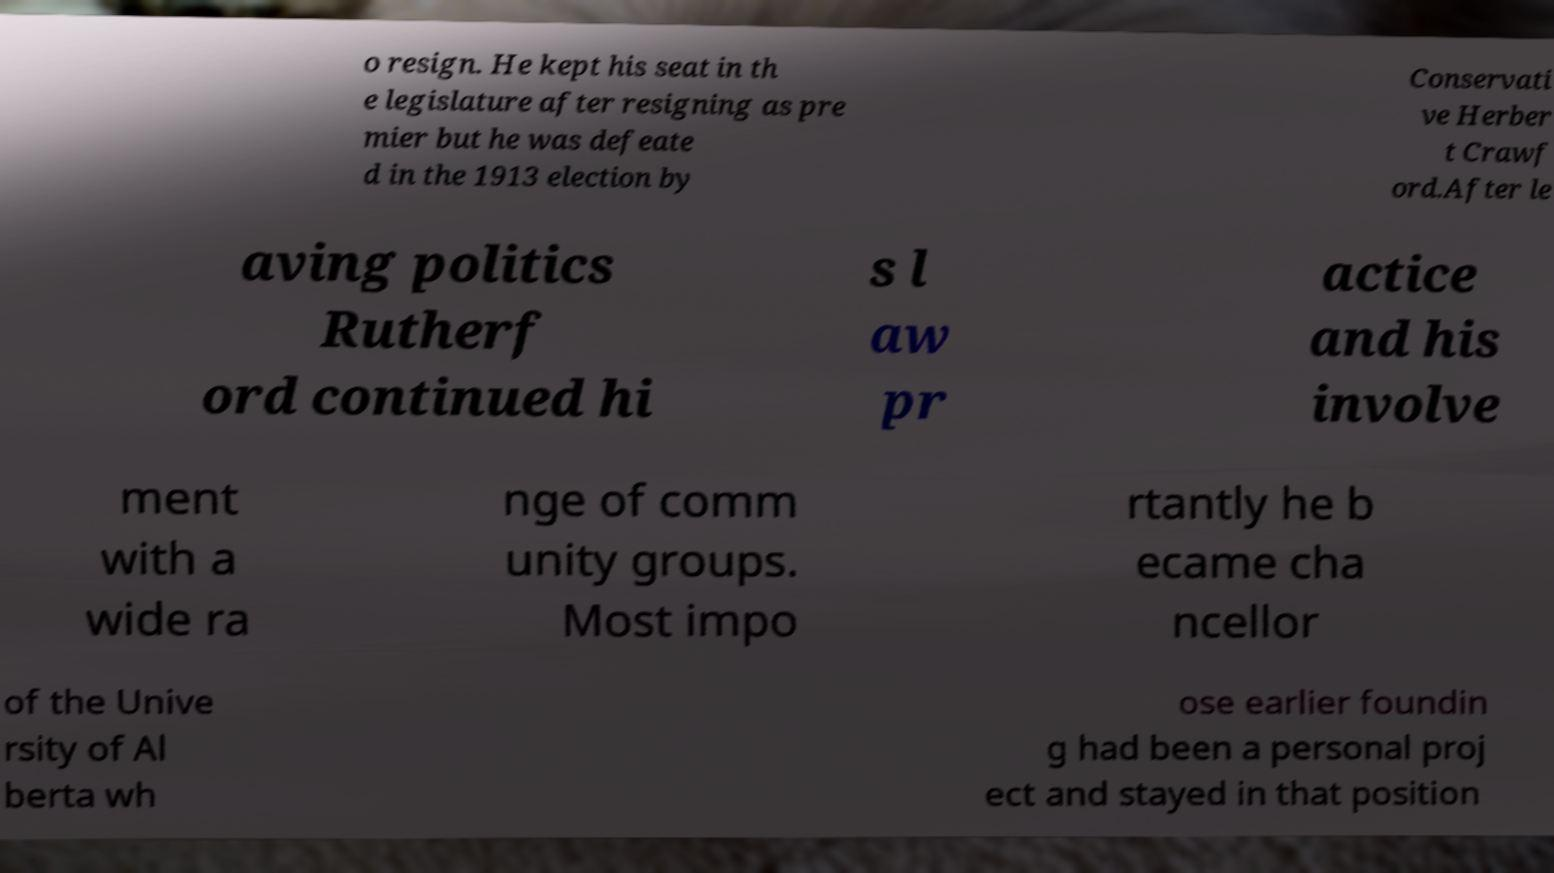Can you accurately transcribe the text from the provided image for me? o resign. He kept his seat in th e legislature after resigning as pre mier but he was defeate d in the 1913 election by Conservati ve Herber t Crawf ord.After le aving politics Rutherf ord continued hi s l aw pr actice and his involve ment with a wide ra nge of comm unity groups. Most impo rtantly he b ecame cha ncellor of the Unive rsity of Al berta wh ose earlier foundin g had been a personal proj ect and stayed in that position 